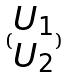<formula> <loc_0><loc_0><loc_500><loc_500>( \begin{matrix} U _ { 1 } \\ U _ { 2 } \end{matrix} )</formula> 